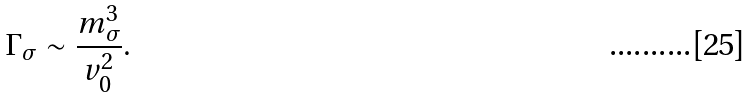<formula> <loc_0><loc_0><loc_500><loc_500>\Gamma _ { \sigma } \sim \frac { m _ { \sigma } ^ { 3 } } { v _ { 0 } ^ { 2 } } .</formula> 